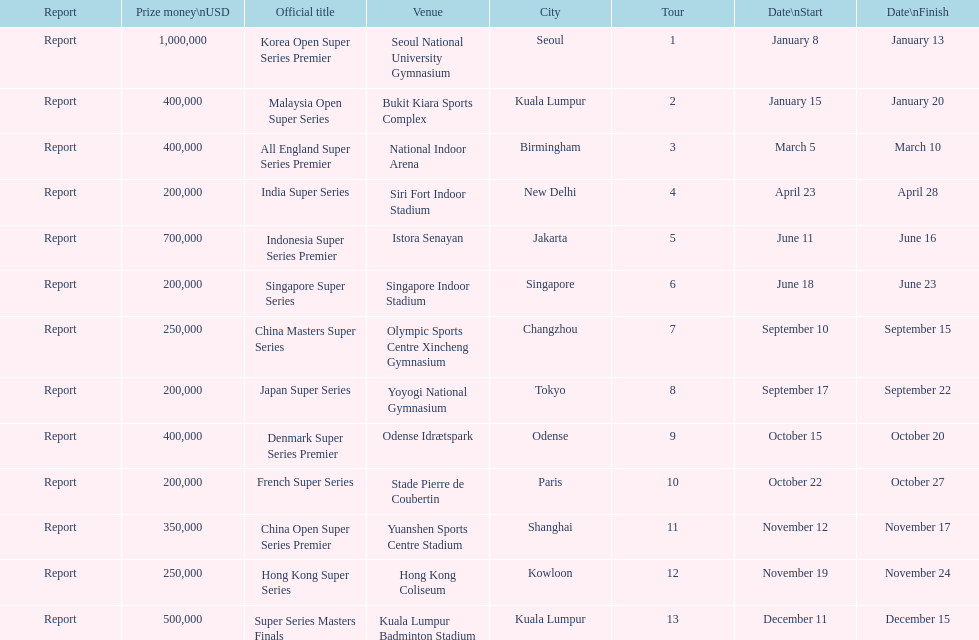Write the full table. {'header': ['Report', 'Prize money\\nUSD', 'Official title', 'Venue', 'City', 'Tour', 'Date\\nStart', 'Date\\nFinish'], 'rows': [['Report', '1,000,000', 'Korea Open Super Series Premier', 'Seoul National University Gymnasium', 'Seoul', '1', 'January 8', 'January 13'], ['Report', '400,000', 'Malaysia Open Super Series', 'Bukit Kiara Sports Complex', 'Kuala Lumpur', '2', 'January 15', 'January 20'], ['Report', '400,000', 'All England Super Series Premier', 'National Indoor Arena', 'Birmingham', '3', 'March 5', 'March 10'], ['Report', '200,000', 'India Super Series', 'Siri Fort Indoor Stadium', 'New Delhi', '4', 'April 23', 'April 28'], ['Report', '700,000', 'Indonesia Super Series Premier', 'Istora Senayan', 'Jakarta', '5', 'June 11', 'June 16'], ['Report', '200,000', 'Singapore Super Series', 'Singapore Indoor Stadium', 'Singapore', '6', 'June 18', 'June 23'], ['Report', '250,000', 'China Masters Super Series', 'Olympic Sports Centre Xincheng Gymnasium', 'Changzhou', '7', 'September 10', 'September 15'], ['Report', '200,000', 'Japan Super Series', 'Yoyogi National Gymnasium', 'Tokyo', '8', 'September 17', 'September 22'], ['Report', '400,000', 'Denmark Super Series Premier', 'Odense Idrætspark', 'Odense', '9', 'October 15', 'October 20'], ['Report', '200,000', 'French Super Series', 'Stade Pierre de Coubertin', 'Paris', '10', 'October 22', 'October 27'], ['Report', '350,000', 'China Open Super Series Premier', 'Yuanshen Sports Centre Stadium', 'Shanghai', '11', 'November 12', 'November 17'], ['Report', '250,000', 'Hong Kong Super Series', 'Hong Kong Coliseum', 'Kowloon', '12', 'November 19', 'November 24'], ['Report', '500,000', 'Super Series Masters Finals', 'Kuala Lumpur Badminton Stadium', 'Kuala Lumpur', '13', 'December 11', 'December 15']]} How many series awarded at least $500,000 in prize money? 3. 